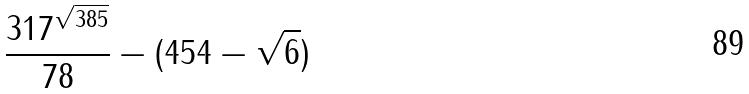<formula> <loc_0><loc_0><loc_500><loc_500>\frac { 3 1 7 ^ { \sqrt { 3 8 5 } } } { 7 8 } - ( 4 5 4 - \sqrt { 6 } )</formula> 